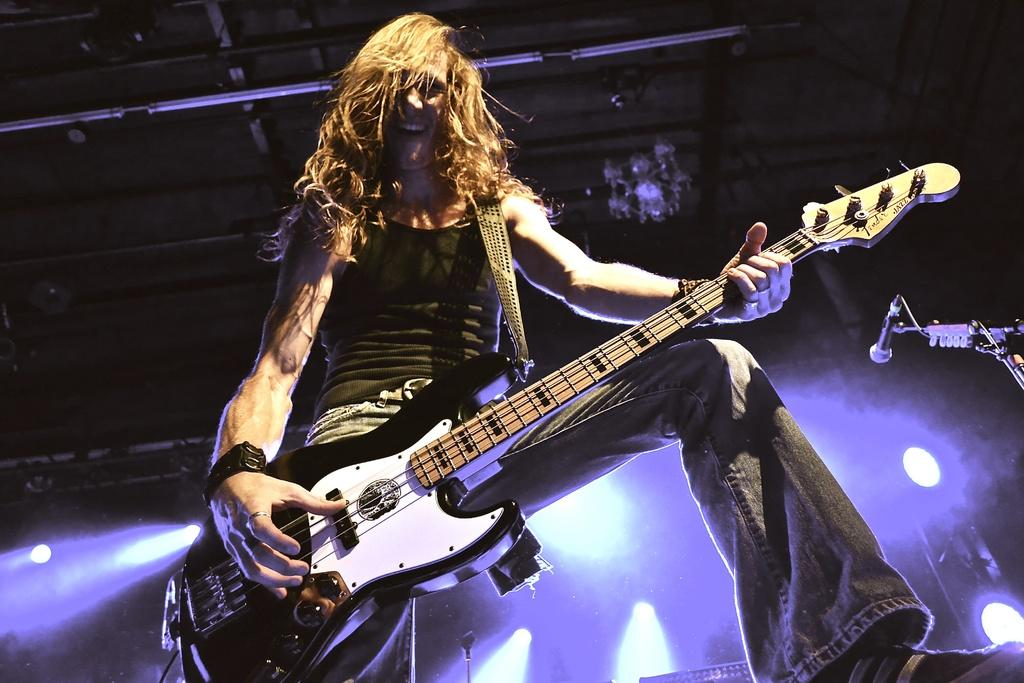What is the person in the image doing? The person is playing the guitar. What object is the person holding while playing the guitar? The person is holding a guitar. What can be seen in the background of the image? There are show lights in the background of the image. Can you tell me how many times the person sneezes while playing the guitar in the image? There is no indication of the person sneezing in the image; they are simply playing the guitar. What type of boundary is present in the image? There is no mention of a boundary in the image; it features a person playing a guitar with show lights in the background. 